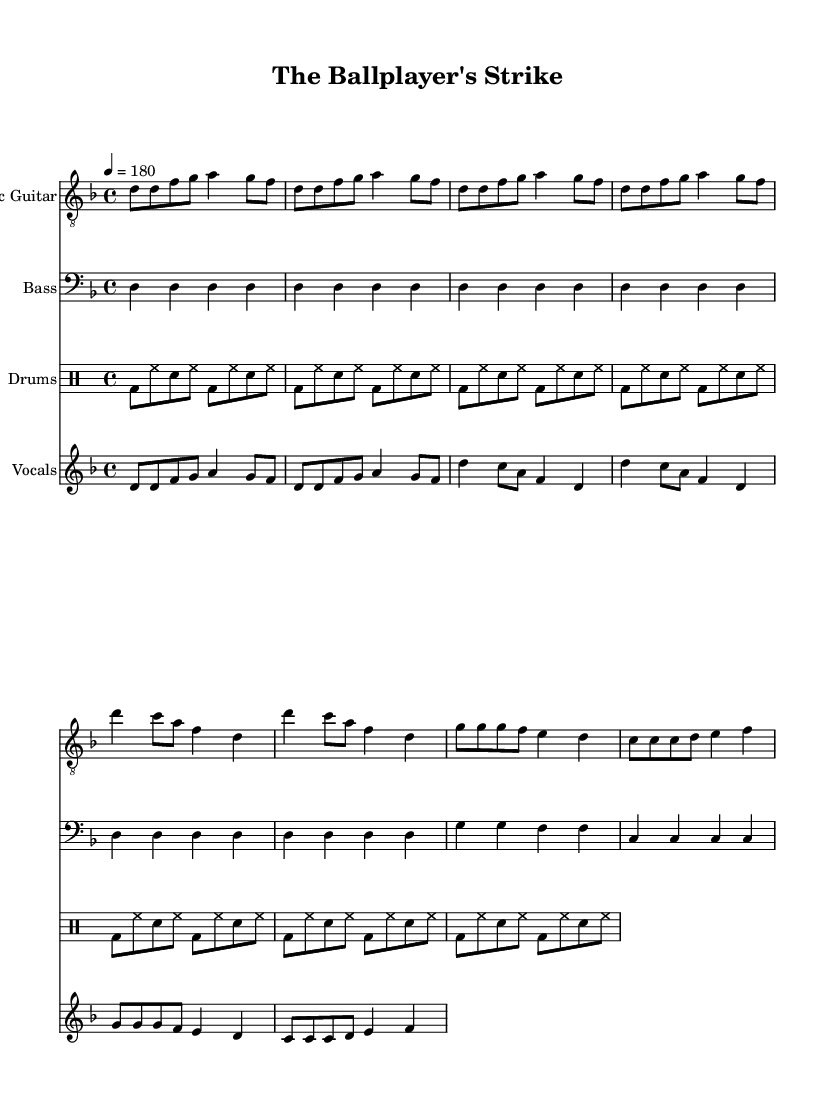What is the key signature of this music? The key signature is indicated at the beginning of the score. It shows one flat (B flat), meaning the key is D minor.
Answer: D minor What is the time signature of this music? The time signature is also shown at the beginning of the score. It is 4/4, meaning there are four beats in a measure and the quarter note gets the beat.
Answer: 4/4 What is the tempo marking for this piece? The tempo is indicated in beats per minute at the start. It shows "4 = 180," meaning the quarter note is to be played at 180 beats per minute.
Answer: 180 How many measures are in the verse? By counting the measures in the vocal part, the verse consists of 4 measures in total.
Answer: 4 What is the primary theme of the lyrics? The lyrics highlight a labor issue by expressing unity among players against the owners in the context of a strike, focusing on rights and dignity.
Answer: Labor issues What is the role of the electric guitar in this piece? The electric guitar plays the melody and maintains the song's driving punk rhythm typical of this genre, supporting the vocal lines effectively.
Answer: Melody What do the repeated phrases in the chorus signify? The repetition emphasizes the call to action for a strike, a common punk motif that promotes solidarity and resistance, making it more memorable and impactful.
Answer: Solidarity 